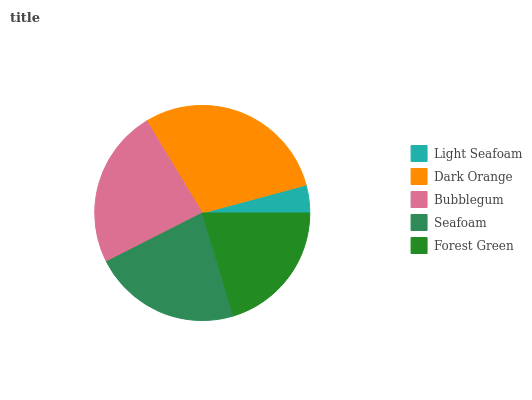Is Light Seafoam the minimum?
Answer yes or no. Yes. Is Dark Orange the maximum?
Answer yes or no. Yes. Is Bubblegum the minimum?
Answer yes or no. No. Is Bubblegum the maximum?
Answer yes or no. No. Is Dark Orange greater than Bubblegum?
Answer yes or no. Yes. Is Bubblegum less than Dark Orange?
Answer yes or no. Yes. Is Bubblegum greater than Dark Orange?
Answer yes or no. No. Is Dark Orange less than Bubblegum?
Answer yes or no. No. Is Seafoam the high median?
Answer yes or no. Yes. Is Seafoam the low median?
Answer yes or no. Yes. Is Light Seafoam the high median?
Answer yes or no. No. Is Light Seafoam the low median?
Answer yes or no. No. 